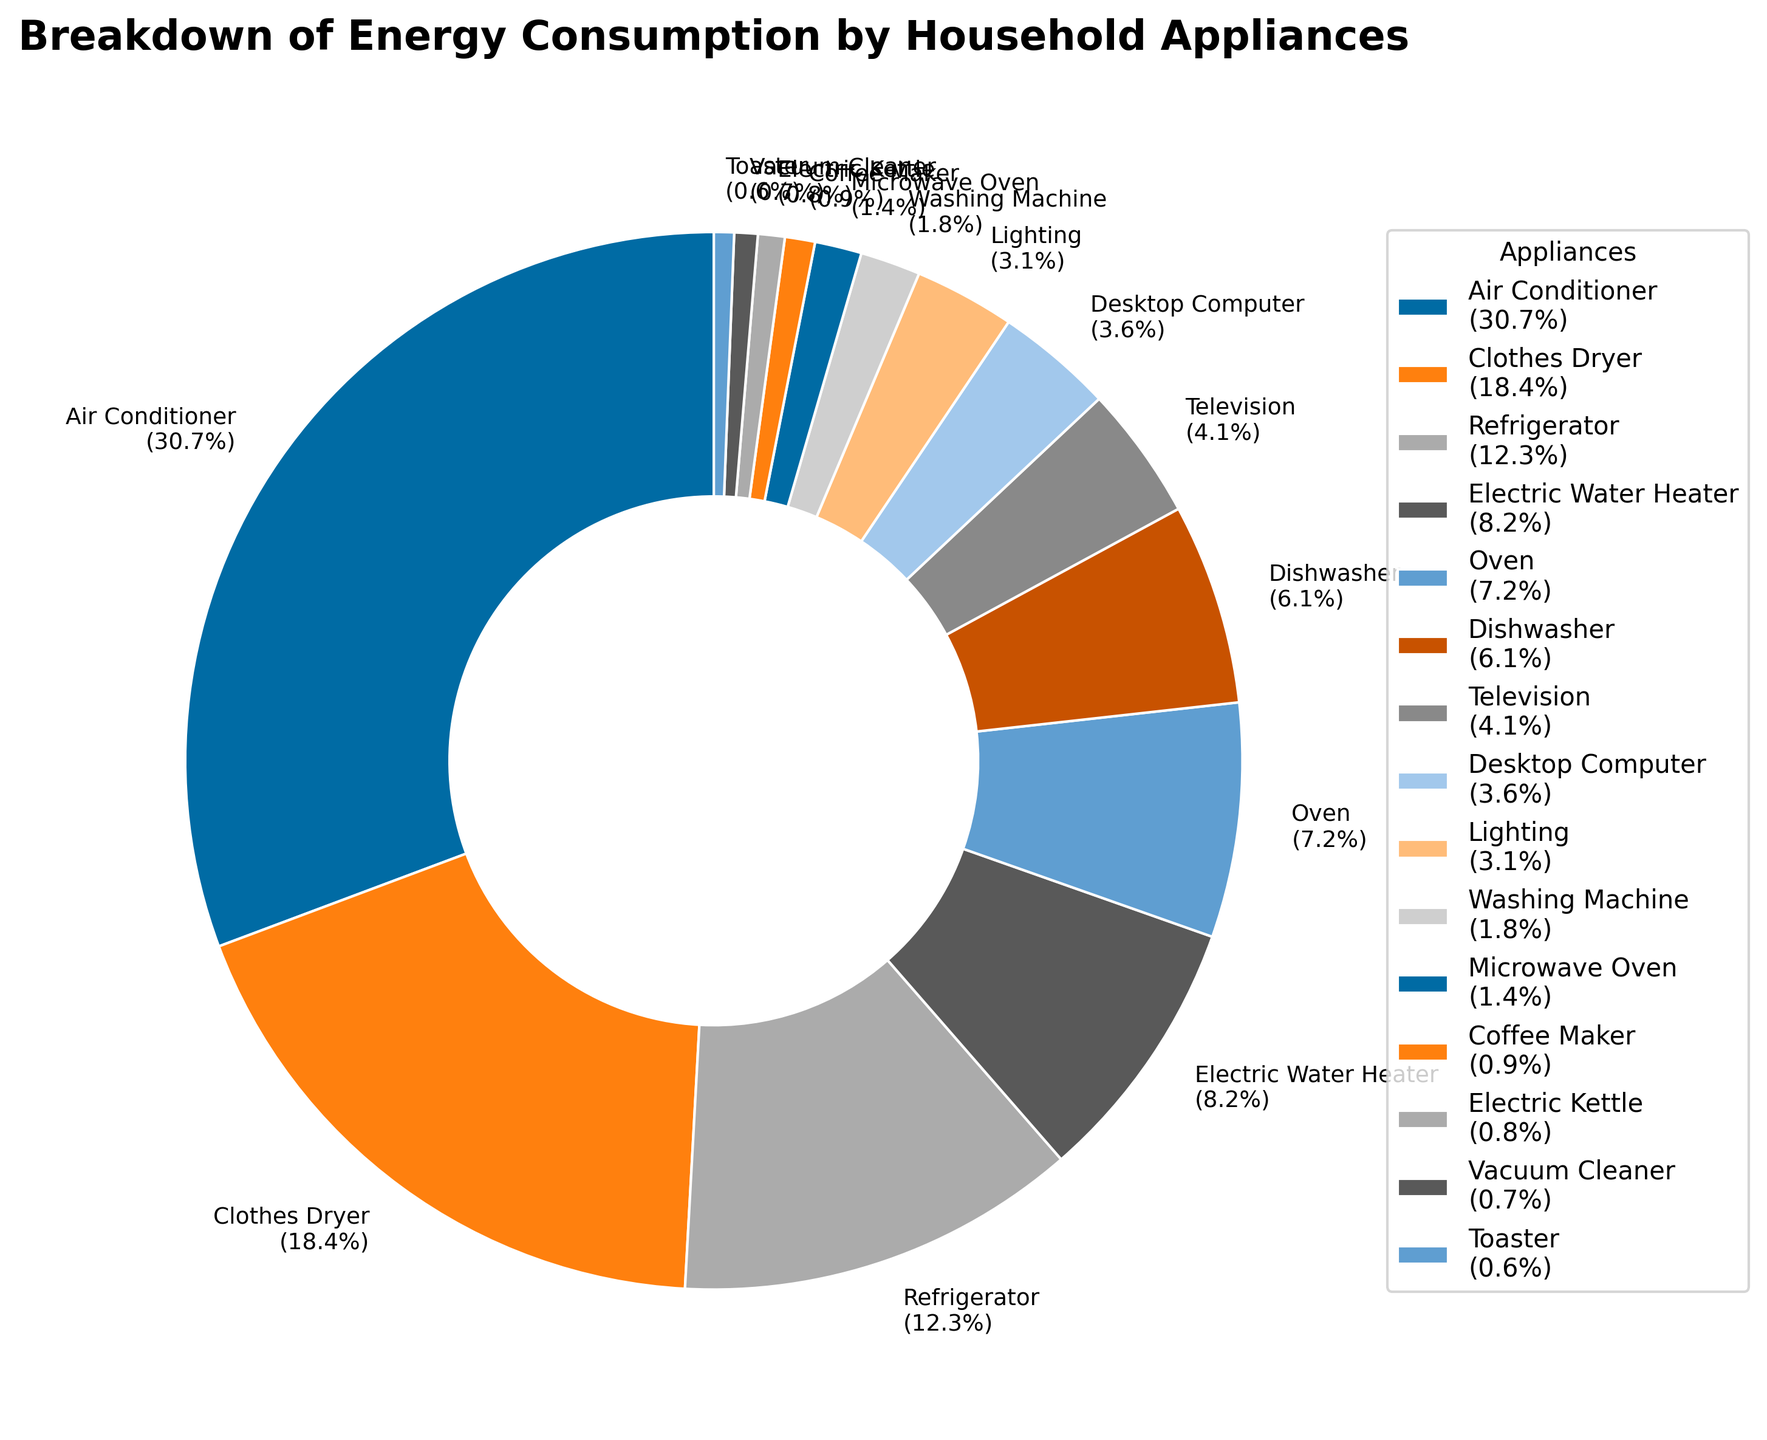Which appliance uses the most energy? The air conditioner has the largest segment in the pie chart, indicating it consumes the most energy. The label shows 1500 kWh/year, which is the highest energy consumption among all appliances.
Answer: Air Conditioner Which appliance consumes more energy, the refrigerator or the electric water heater? By comparing the size of the pie chart segments, the refrigerator's segment is larger than the electric water heater's segment. The labels confirm this with 600 kWh/year for the refrigerator and 400 kWh/year for the electric water heater.
Answer: Refrigerator What percentage of the total energy consumption is used by the air conditioner and the refrigerator combined? The air conditioner's segment is labeled 1500 kWh/year (48.7%) and the refrigerator is 600 kWh/year (19.5%). Adding these percentages together gives 48.7% + 19.5% = 68.2%.
Answer: 68.2% How does the energy consumption of the washing machine compare to the dishwasher? The pie chart shows that the washing machine's segment is much smaller than the dishwasher's. The labels indicate the washing machine uses 90 kWh/year (2.9%), while the dishwasher uses 300 kWh/year (9.7%). Thus, the washing machine consumes less energy.
Answer: Washing machine consumes less Which appliances together account for less than 10% of total energy consumption? List at least two. The segments for microwave oven (2.3%), coffee maker (1.5%), electric kettle (1.3%), vacuum cleaner (1.1%), and toaster (1%) are smaller and add up to less than 10%. Any two of these appliances together would account for less than 10%. For example, the microwave oven and coffee maker together account for 2.3% + 1.5% = 3.8%.
Answer: Microwave oven, coffee maker What is the total energy consumption of all heating-related appliances (air conditioner, electric water heater, oven, and toaster)? Summing the energy consumption from the labels: Air conditioner (1500 kWh/year) + Electric water heater (400 kWh/year) + Oven (350 kWh/year) + Toaster (30 kWh/year). The total is 1500 + 400 + 350 + 30 = 2280 kWh/year.
Answer: 2280 kWh/year What is the average energy consumption for appliances that consume less than 100 kWh/year? The appliances consuming less than 100 kWh/year are the washing machine (90 kWh/year), microwave oven (70 kWh/year), coffee maker (45 kWh/year), electric kettle (40 kWh/year), vacuum cleaner (35 kWh/year), and toaster (30 kWh/year). Summing these values: 90 + 70 + 45 + 40 + 35 + 30 = 310. Dividing by 6 appliances, the average is 310/6 ≈ 51.7 kWh/year.
Answer: 51.7 kWh/year What is the combined percentage of energy consumption by the television and the desktop computer? From the chart, the television uses 200 kWh/year (6.5%) and the desktop computer uses 175 kWh/year (5.7%). Adding these percentages together gives 6.5% + 5.7% = 12.2%.
Answer: 12.2% Which appliance has the closest energy consumption to the desktop computer? By looking at the pie chart labels, the desktop computer consumes 175 kWh/year. The television is the closest, which uses 200 kWh/year.
Answer: Television 